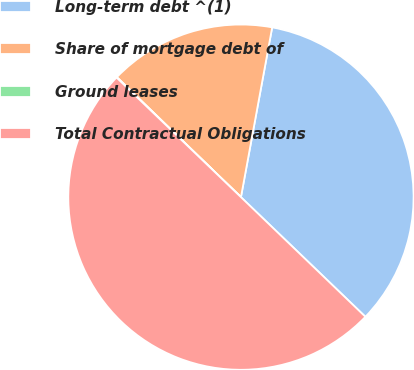Convert chart. <chart><loc_0><loc_0><loc_500><loc_500><pie_chart><fcel>Long-term debt ^(1)<fcel>Share of mortgage debt of<fcel>Ground leases<fcel>Total Contractual Obligations<nl><fcel>34.29%<fcel>15.66%<fcel>0.05%<fcel>50.0%<nl></chart> 